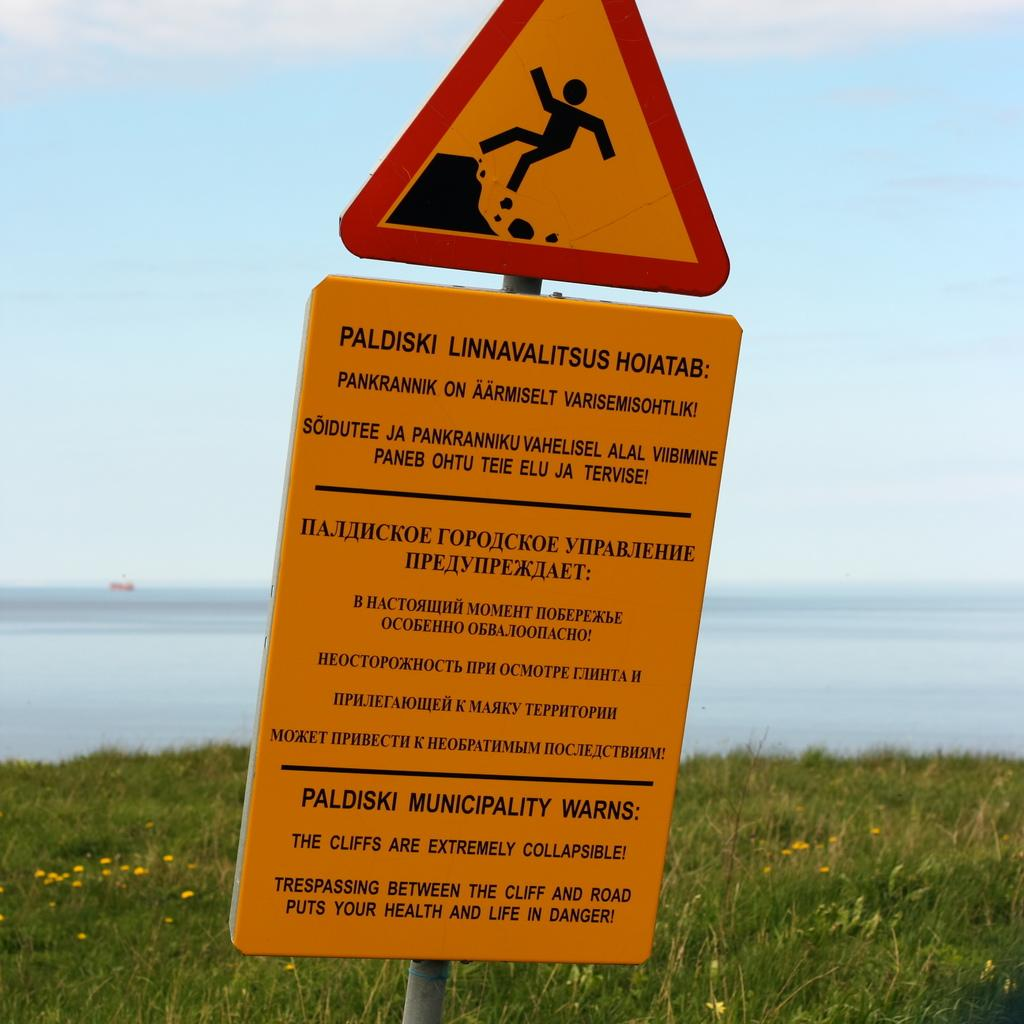<image>
Give a short and clear explanation of the subsequent image. An orange danger sign, written in another language, is posted in a green field, in front of a body of water. 